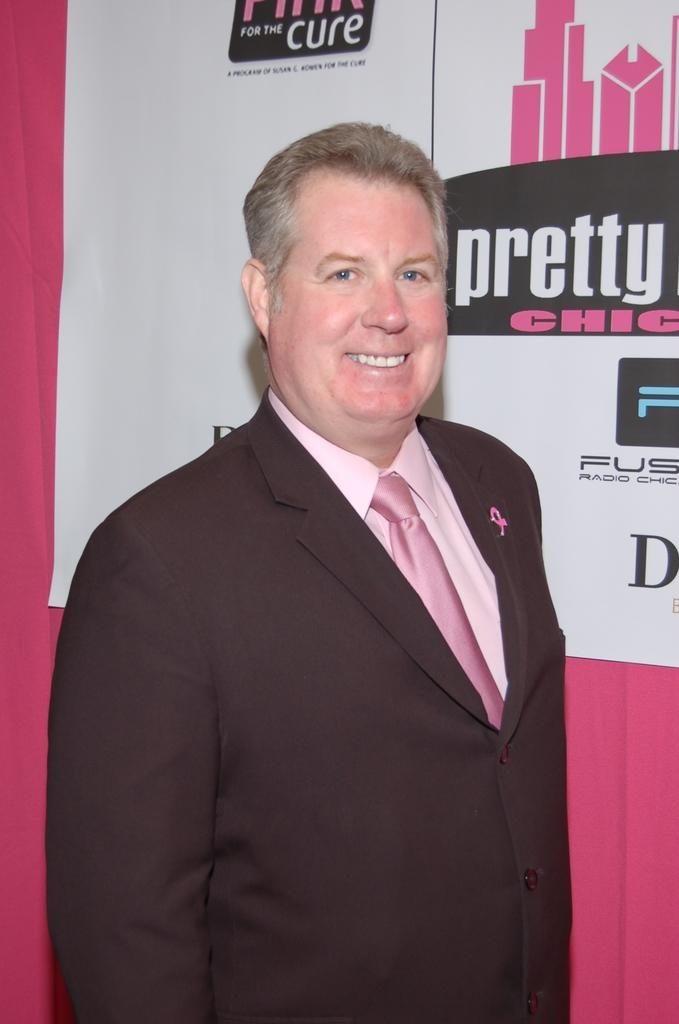Who is the main subject in the image? There is a person in the center of the image. What is the person wearing? The person is wearing a suit. What is the person's facial expression? The person is smiling. What is the person's posture in the image? The person is standing. What can be seen in the background of the image? There is a pink color curtain and a banner with text on it in the background. What is the sun's role in causing the person to smile in the image? The sun is not present in the image, and therefore it cannot be attributed to causing the person's smile. 